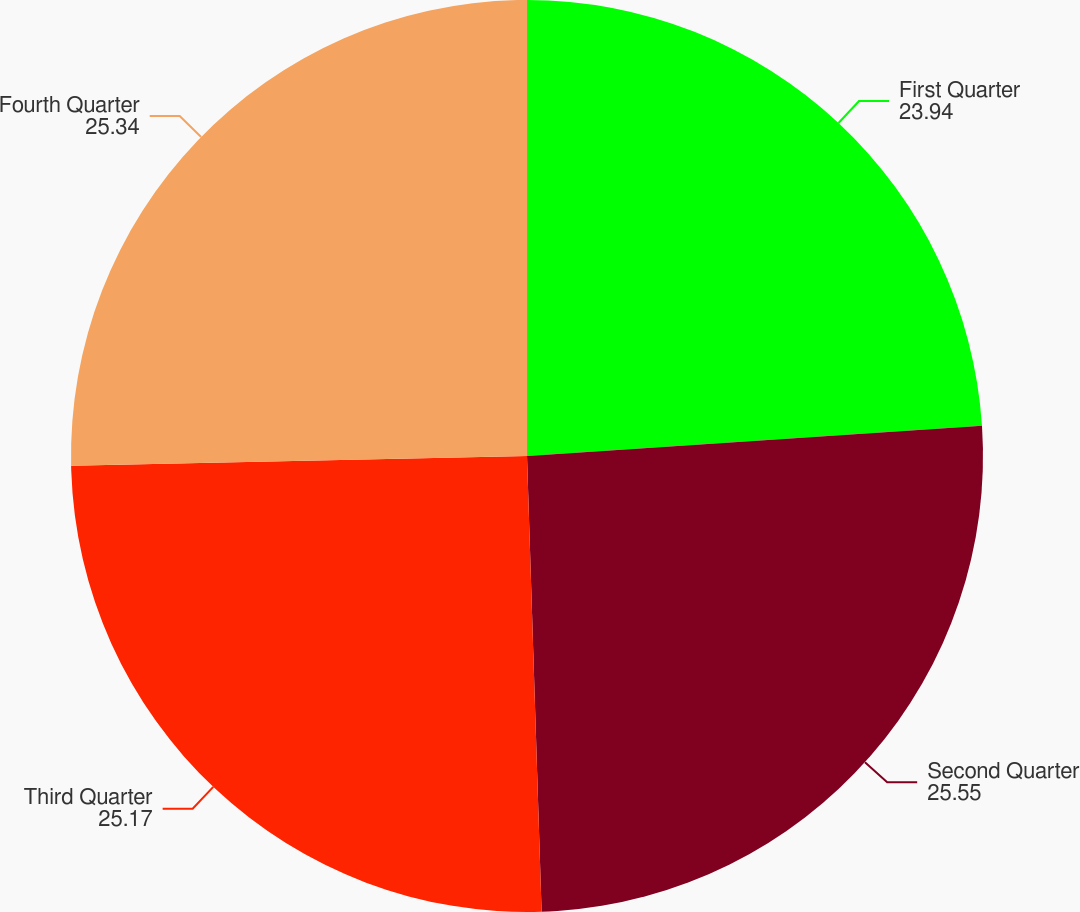Convert chart to OTSL. <chart><loc_0><loc_0><loc_500><loc_500><pie_chart><fcel>First Quarter<fcel>Second Quarter<fcel>Third Quarter<fcel>Fourth Quarter<nl><fcel>23.94%<fcel>25.55%<fcel>25.17%<fcel>25.34%<nl></chart> 